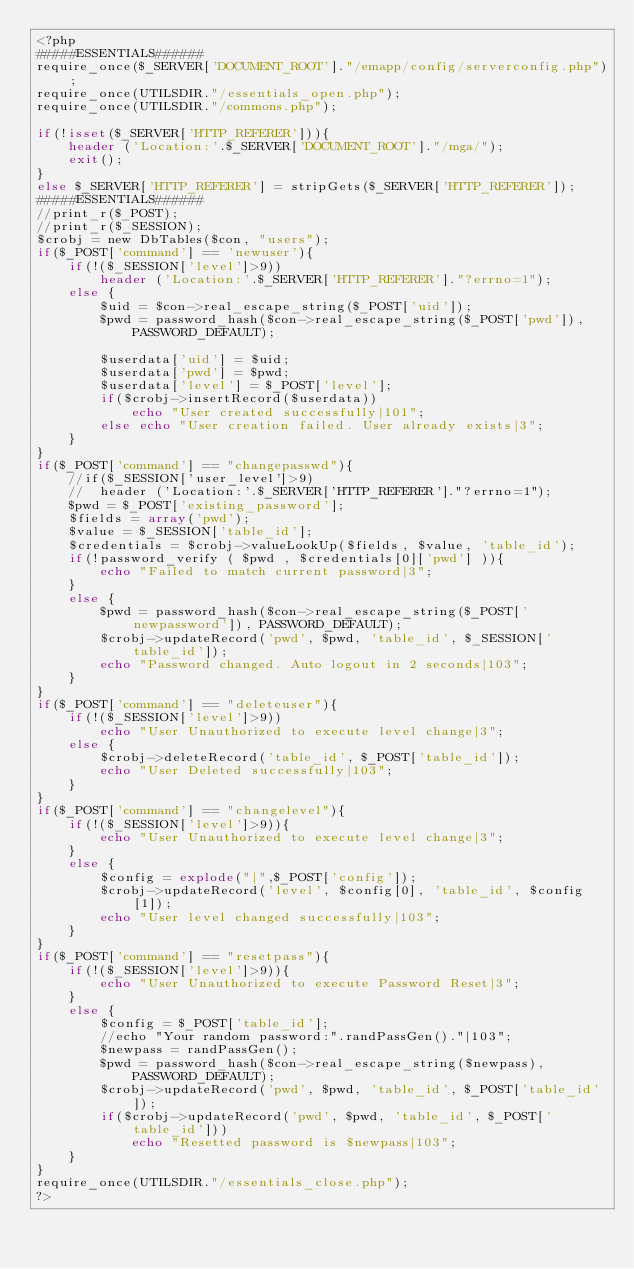Convert code to text. <code><loc_0><loc_0><loc_500><loc_500><_PHP_><?php
#####ESSENTIALS######
require_once($_SERVER['DOCUMENT_ROOT']."/emapp/config/serverconfig.php");
require_once(UTILSDIR."/essentials_open.php");
require_once(UTILSDIR."/commons.php");

if(!isset($_SERVER['HTTP_REFERER'])){
	header ('Location:'.$_SERVER['DOCUMENT_ROOT']."/mga/");
	exit();
}
else $_SERVER['HTTP_REFERER'] = stripGets($_SERVER['HTTP_REFERER']);
#####ESSENTIALS######
//print_r($_POST);
//print_r($_SESSION);
$crobj = new DbTables($con, "users");
if($_POST['command'] == 'newuser'){
	if(!($_SESSION['level']>9))
		header ('Location:'.$_SERVER['HTTP_REFERER']."?errno=1");
	else {
		$uid = $con->real_escape_string($_POST['uid']);
		$pwd = password_hash($con->real_escape_string($_POST['pwd']), PASSWORD_DEFAULT);

		$userdata['uid'] = $uid;
		$userdata['pwd'] = $pwd;
		$userdata['level'] = $_POST['level'];
		if($crobj->insertRecord($userdata))
			echo "User created successfully|101";
		else echo "User creation failed. User already exists|3";
	}
}
if($_POST['command'] == "changepasswd"){
	//if($_SESSION['user_level']>9)
	//	header ('Location:'.$_SERVER['HTTP_REFERER']."?errno=1");
	$pwd = $_POST['existing_password'];
	$fields = array('pwd');
	$value = $_SESSION['table_id'];
	$credentials = $crobj->valueLookUp($fields, $value, 'table_id');
	if(!password_verify ( $pwd , $credentials[0]['pwd'] )){
		echo "Failed to match current password|3";
	}
	else {
		$pwd = password_hash($con->real_escape_string($_POST['newpassword']), PASSWORD_DEFAULT);
		$crobj->updateRecord('pwd', $pwd, 'table_id', $_SESSION['table_id']);
		echo "Password changed. Auto logout in 2 seconds|103";
	}
}
if($_POST['command'] == "deleteuser"){
	if(!($_SESSION['level']>9))
		echo "User Unauthorized to execute level change|3";
	else {
		$crobj->deleteRecord('table_id', $_POST['table_id']);
		echo "User Deleted successfully|103";
	}
}
if($_POST['command'] == "changelevel"){
	if(!($_SESSION['level']>9)){
		echo "User Unauthorized to execute level change|3";
	}
	else {
		$config = explode("|",$_POST['config']);
		$crobj->updateRecord('level', $config[0], 'table_id', $config[1]);
		echo "User level changed successfully|103";
	}
}
if($_POST['command'] == "resetpass"){
	if(!($_SESSION['level']>9)){
		echo "User Unauthorized to execute Password Reset|3";
	}
	else {
		$config = $_POST['table_id'];
		//echo "Your random password:".randPassGen()."|103";
		$newpass = randPassGen();
		$pwd = password_hash($con->real_escape_string($newpass), PASSWORD_DEFAULT);
		$crobj->updateRecord('pwd', $pwd, 'table_id', $_POST['table_id']);
		if($crobj->updateRecord('pwd', $pwd, 'table_id', $_POST['table_id']))
			echo "Resetted password is $newpass|103";
	}
}
require_once(UTILSDIR."/essentials_close.php");
?>
</code> 